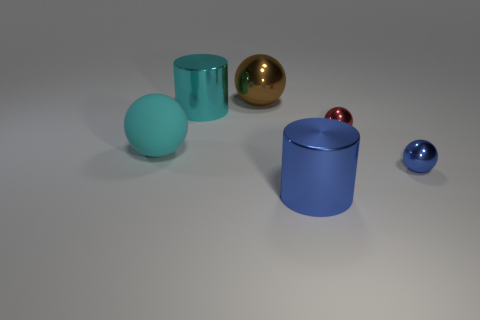What size is the blue thing that is the same shape as the red thing?
Provide a succinct answer. Small. What number of small objects are either cyan balls or blue objects?
Make the answer very short. 1. Does the cylinder on the right side of the brown thing have the same material as the big cylinder left of the large blue metal cylinder?
Give a very brief answer. Yes. What material is the large cylinder behind the large rubber thing?
Offer a terse response. Metal. What number of metal objects are either tiny things or large cyan things?
Keep it short and to the point. 3. What is the color of the big metallic cylinder in front of the metallic object to the right of the tiny red shiny ball?
Give a very brief answer. Blue. Does the red object have the same material as the big cylinder that is in front of the big rubber ball?
Ensure brevity in your answer.  Yes. What is the color of the big shiny cylinder that is on the left side of the metal cylinder in front of the small metallic thing that is behind the tiny blue object?
Keep it short and to the point. Cyan. Is there any other thing that is the same shape as the brown thing?
Provide a short and direct response. Yes. Is the number of large cyan metal things greater than the number of blue things?
Your response must be concise. No. 